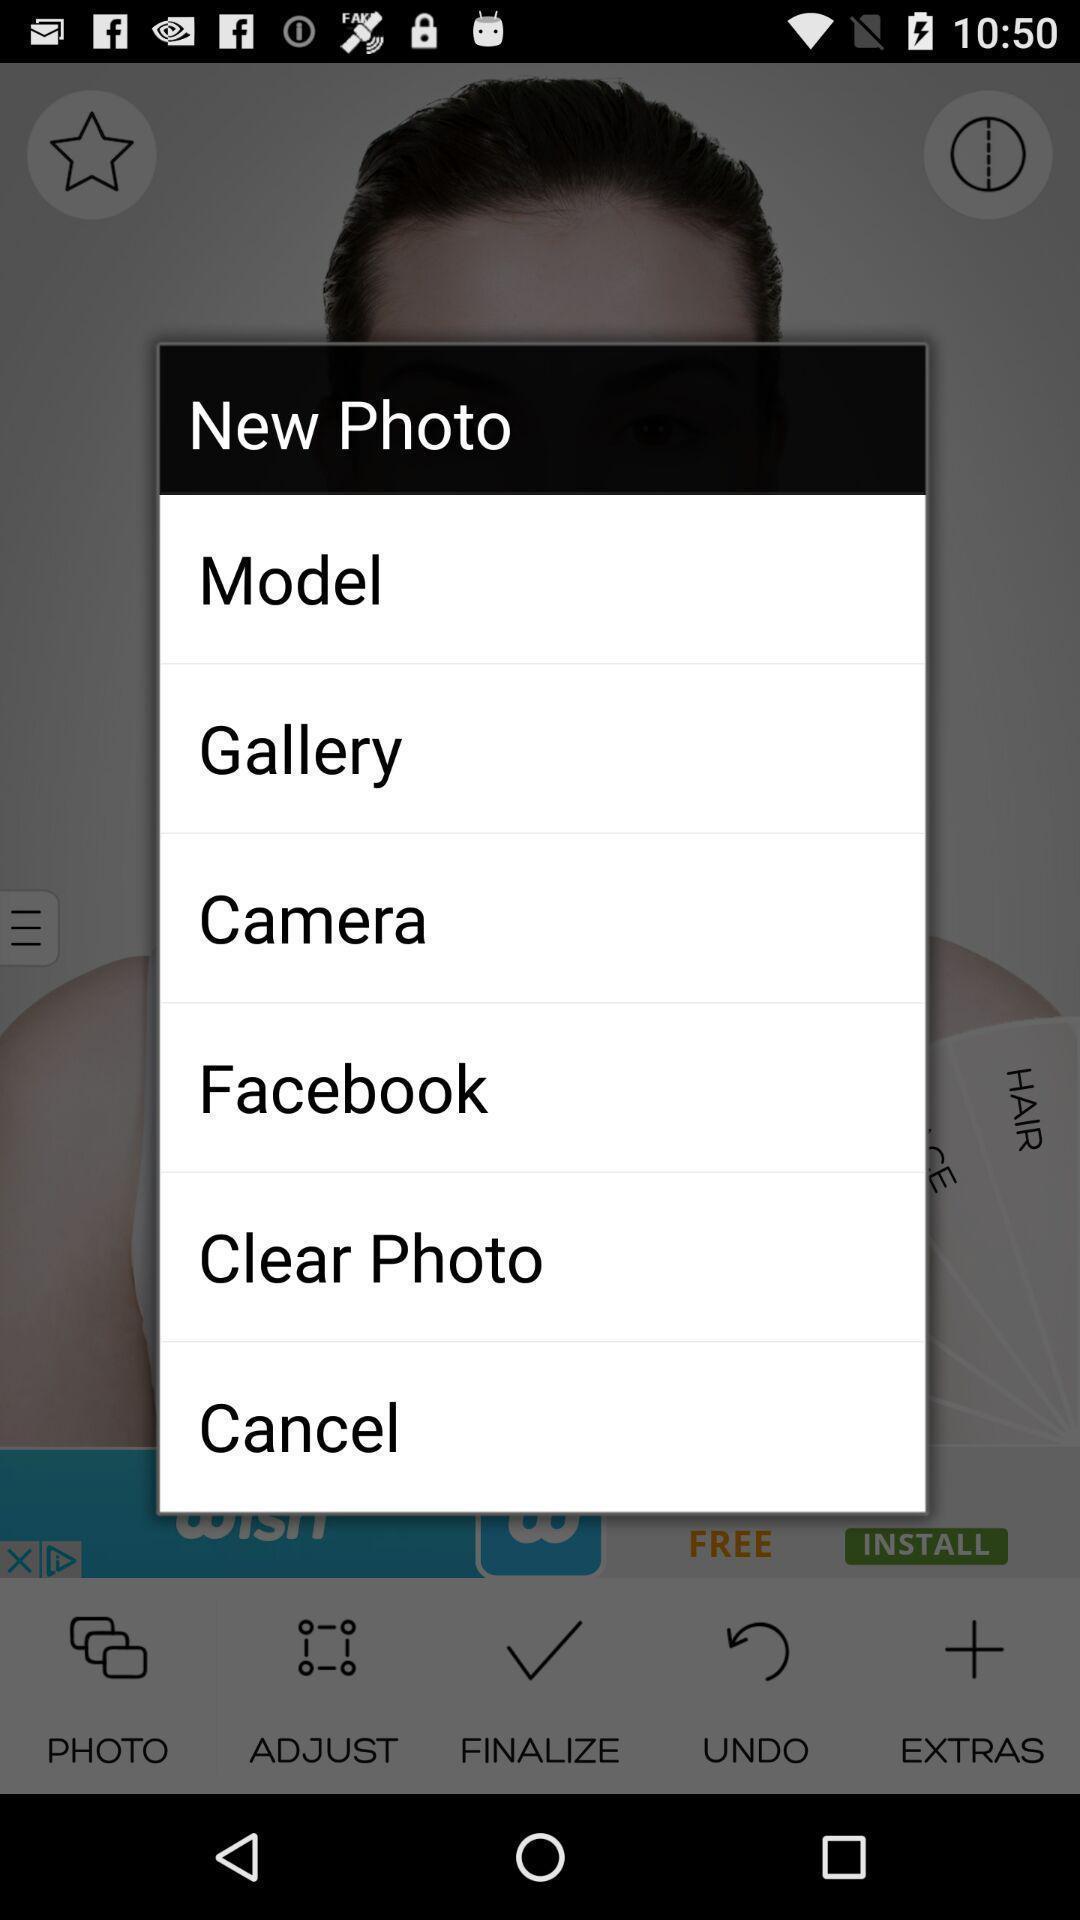Give me a narrative description of this picture. Popup showing list of options. 